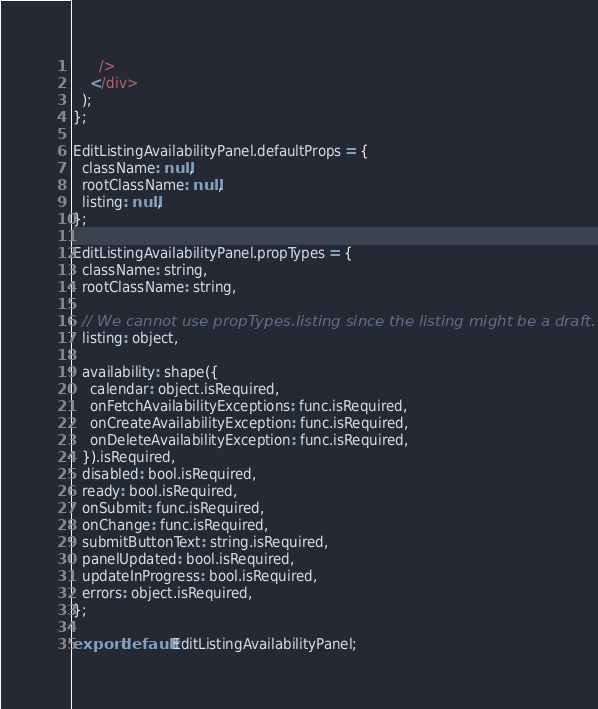Convert code to text. <code><loc_0><loc_0><loc_500><loc_500><_JavaScript_>      />
    </div>
  );
};

EditListingAvailabilityPanel.defaultProps = {
  className: null,
  rootClassName: null,
  listing: null,
};

EditListingAvailabilityPanel.propTypes = {
  className: string,
  rootClassName: string,

  // We cannot use propTypes.listing since the listing might be a draft.
  listing: object,

  availability: shape({
    calendar: object.isRequired,
    onFetchAvailabilityExceptions: func.isRequired,
    onCreateAvailabilityException: func.isRequired,
    onDeleteAvailabilityException: func.isRequired,
  }).isRequired,
  disabled: bool.isRequired,
  ready: bool.isRequired,
  onSubmit: func.isRequired,
  onChange: func.isRequired,
  submitButtonText: string.isRequired,
  panelUpdated: bool.isRequired,
  updateInProgress: bool.isRequired,
  errors: object.isRequired,
};

export default EditListingAvailabilityPanel;
</code> 